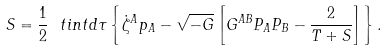Convert formula to latex. <formula><loc_0><loc_0><loc_500><loc_500>S = \frac { 1 } { 2 } \ t i n t d \tau \left \{ \dot { \zeta } ^ { A } p _ { A } - \sqrt { - G } \left [ G ^ { A B } P _ { A } P _ { B } - \frac { 2 } { T + S } \right ] \right \} .</formula> 